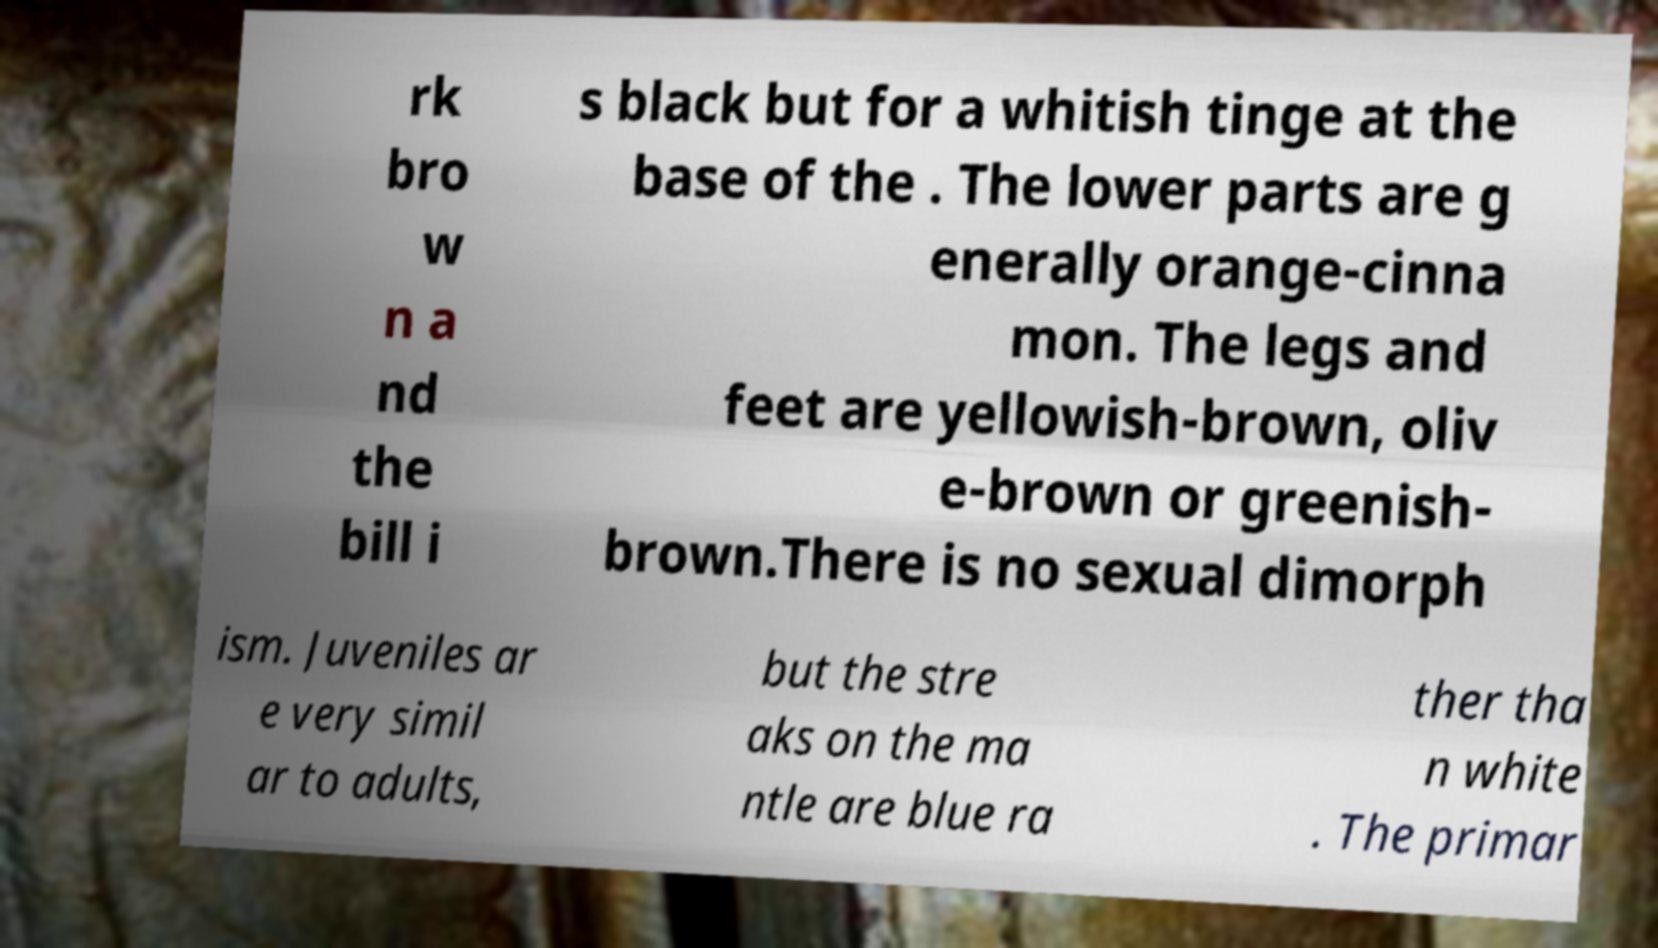There's text embedded in this image that I need extracted. Can you transcribe it verbatim? rk bro w n a nd the bill i s black but for a whitish tinge at the base of the . The lower parts are g enerally orange-cinna mon. The legs and feet are yellowish-brown, oliv e-brown or greenish- brown.There is no sexual dimorph ism. Juveniles ar e very simil ar to adults, but the stre aks on the ma ntle are blue ra ther tha n white . The primar 